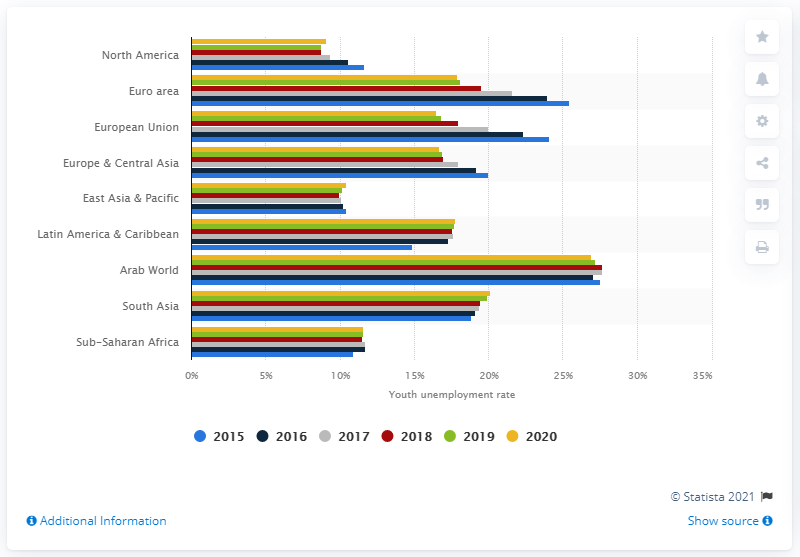Draw attention to some important aspects in this diagram. In 2020, the youth unemployment rate in the Arab world was 27.06%. 